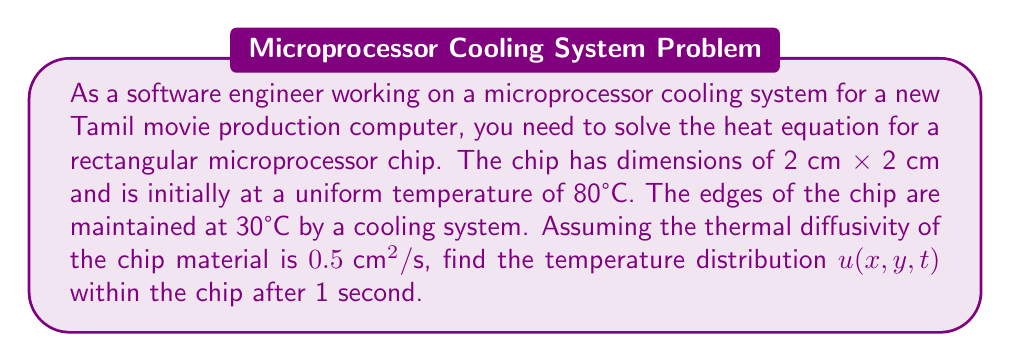Teach me how to tackle this problem. To solve this problem, we need to use the 2D heat equation with appropriate boundary and initial conditions. Let's approach this step-by-step:

1) The 2D heat equation is given by:

   $$\frac{\partial u}{\partial t} = \alpha \left(\frac{\partial^2 u}{\partial x^2} + \frac{\partial^2 u}{\partial y^2}\right)$$

   where $\alpha = 0.5 \text{ cm}^2/\text{s}$ is the thermal diffusivity.

2) The boundary conditions are:
   
   $u(0,y,t) = u(2,y,t) = u(x,0,t) = u(x,2,t) = 30°C$

3) The initial condition is:
   
   $u(x,y,0) = 80°C$

4) We can solve this using separation of variables. Let $u(x,y,t) = X(x)Y(y)T(t)$.

5) Substituting into the heat equation and separating variables:

   $$\frac{T'(t)}{0.5T(t)} = \frac{X''(x)}{X(x)} + \frac{Y''(y)}{Y(y)} = -\lambda^2$$

6) This gives us three ODEs:
   
   $T'(t) = -0.5\lambda^2 T(t)$
   $X''(x) = -\mu^2 X(x)$
   $Y''(y) = -\nu^2 Y(y)$

   where $\lambda^2 = \mu^2 + \nu^2$

7) Solving these with the boundary conditions:

   $X(x) = A \sin(\frac{m\pi x}{2})$, $m = 1,2,3,...$
   $Y(y) = B \sin(\frac{n\pi y}{2})$, $n = 1,2,3,...$
   $T(t) = C e^{-0.5(\frac{m^2\pi^2}{4} + \frac{n^2\pi^2}{4})t}$

8) The general solution is:

   $$u(x,y,t) = 30 + \sum_{m=1}^{\infty}\sum_{n=1}^{\infty} A_{mn} \sin(\frac{m\pi x}{2})\sin(\frac{n\pi y}{2})e^{-0.5(\frac{m^2\pi^2}{4} + \frac{n^2\pi^2}{4})t}$$

9) Using the initial condition to find $A_{mn}$:

   $$A_{mn} = \frac{4}{4} \int_0^2\int_0^2 50 \sin(\frac{m\pi x}{2})\sin(\frac{n\pi y}{2}) dx dy = \frac{200}{mn\pi^2}(1-(-1)^m)(1-(-1)^n)$$

10) Therefore, the final solution is:

    $$u(x,y,t) = 30 + \sum_{m=1,3,5,...}^{\infty}\sum_{n=1,3,5,...}^{\infty} \frac{800}{mn\pi^2} \sin(\frac{m\pi x}{2})\sin(\frac{n\pi y}{2})e^{-0.5(\frac{m^2\pi^2}{4} + \frac{n^2\pi^2}{4})t}$$

11) For $t = 1$ second, we can evaluate this expression numerically.
Answer: The temperature distribution $u(x,y,t)$ within the chip after 1 second is given by:

$$u(x,y,1) = 30 + \sum_{m=1,3,5,...}^{\infty}\sum_{n=1,3,5,...}^{\infty} \frac{800}{mn\pi^2} \sin(\frac{m\pi x}{2})\sin(\frac{n\pi y}{2})e^{-0.5(\frac{m^2\pi^2}{4} + \frac{n^2\pi^2}{4})}$$

This series converges rapidly, and the first few terms provide a good approximation of the temperature distribution. 